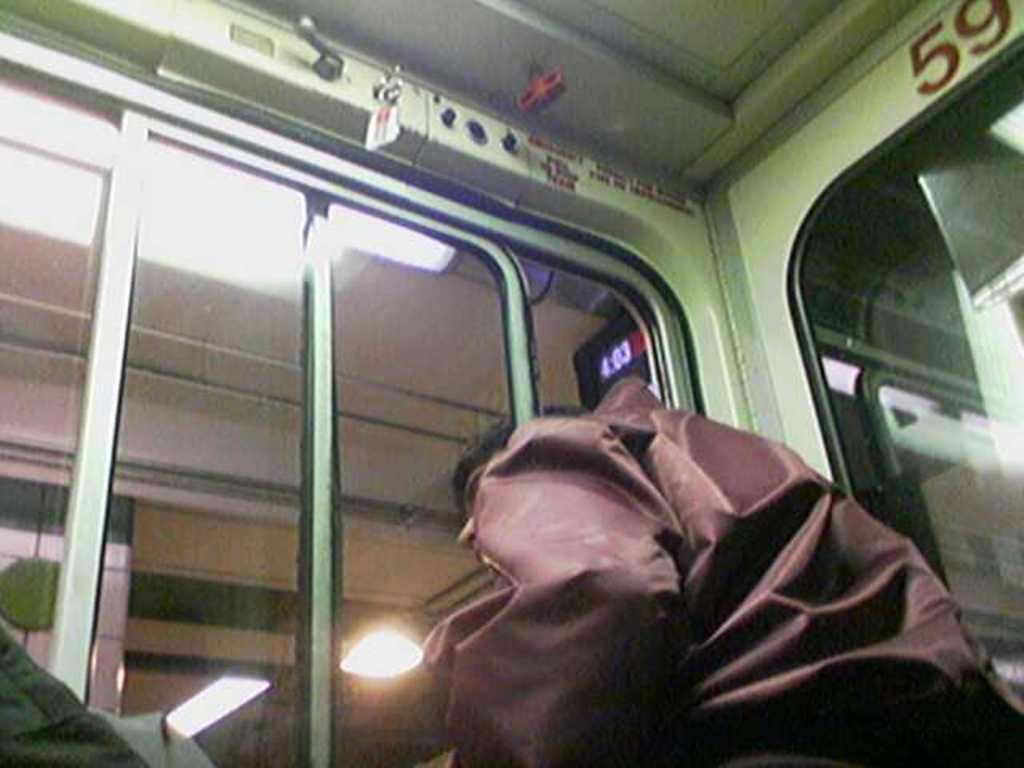Who is present in the image? There is a man in the image. What is the man wearing? The man is wearing a brown jacket. What mode of transportation does the image appear to depict? The man appears to be standing in a train. What can be seen in the front of the image? There is a window or a door visible in the front of the image. What type of arithmetic problem is the man solving in the image? There is no indication in the image that the man is solving an arithmetic problem. What type of judge is depicted in the image? There is no judge present in the image; it features a man standing in a train. 